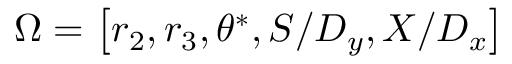Convert formula to latex. <formula><loc_0><loc_0><loc_500><loc_500>\Omega = \left [ r _ { 2 } , r _ { 3 } , \theta ^ { * } , S / D _ { y } , X / D _ { x } \right ]</formula> 